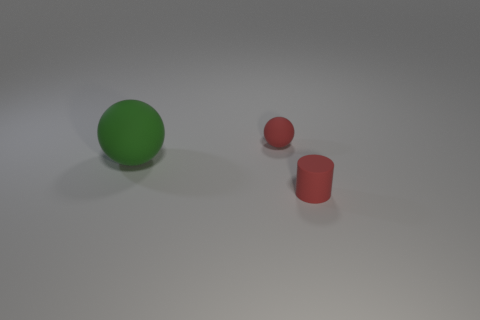Add 2 tiny matte cylinders. How many objects exist? 5 Subtract all green balls. How many balls are left? 1 Subtract all cylinders. How many objects are left? 2 Subtract 2 spheres. How many spheres are left? 0 Subtract all yellow cylinders. How many gray balls are left? 0 Subtract all tiny rubber cylinders. Subtract all red matte spheres. How many objects are left? 1 Add 2 tiny rubber things. How many tiny rubber things are left? 4 Add 3 green objects. How many green objects exist? 4 Subtract 1 green spheres. How many objects are left? 2 Subtract all gray cylinders. Subtract all brown balls. How many cylinders are left? 1 